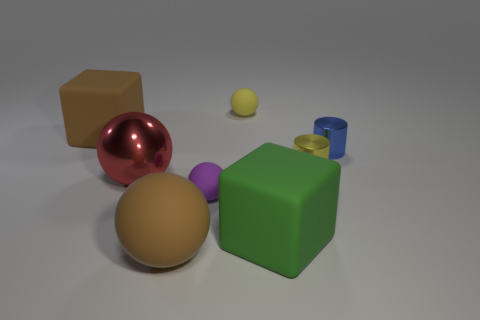What color is the other tiny object that is the same material as the small blue thing?
Offer a very short reply. Yellow. What is the small object right of the yellow cylinder made of?
Offer a terse response. Metal. There is a small purple rubber thing; is it the same shape as the blue metal object to the right of the red ball?
Offer a terse response. No. What material is the object that is in front of the small purple rubber thing and to the right of the purple rubber object?
Give a very brief answer. Rubber. What color is the other matte ball that is the same size as the purple rubber ball?
Your response must be concise. Yellow. Is the brown block made of the same material as the brown object that is on the right side of the large red metal thing?
Provide a succinct answer. Yes. What number of other objects are there of the same size as the yellow cylinder?
Offer a very short reply. 3. There is a tiny yellow object that is behind the matte block that is to the left of the large metal thing; are there any big brown balls to the right of it?
Give a very brief answer. No. What is the size of the purple ball?
Give a very brief answer. Small. There is a rubber block right of the yellow rubber sphere; what is its size?
Give a very brief answer. Large. 